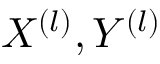Convert formula to latex. <formula><loc_0><loc_0><loc_500><loc_500>X ^ { ( l ) } , Y ^ { ( l ) }</formula> 